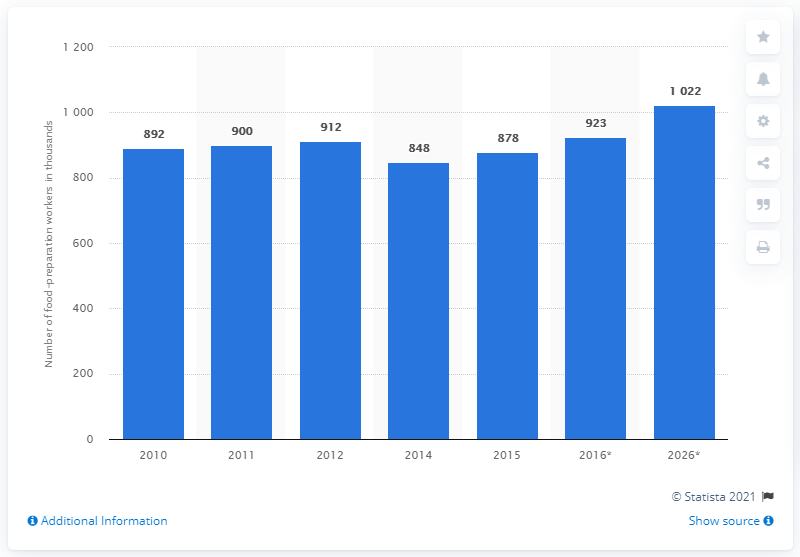Highlight a few significant elements in this photo. According to projections, the number of food preparation workers in the United States is expected to reach 10,220 by 2026. 